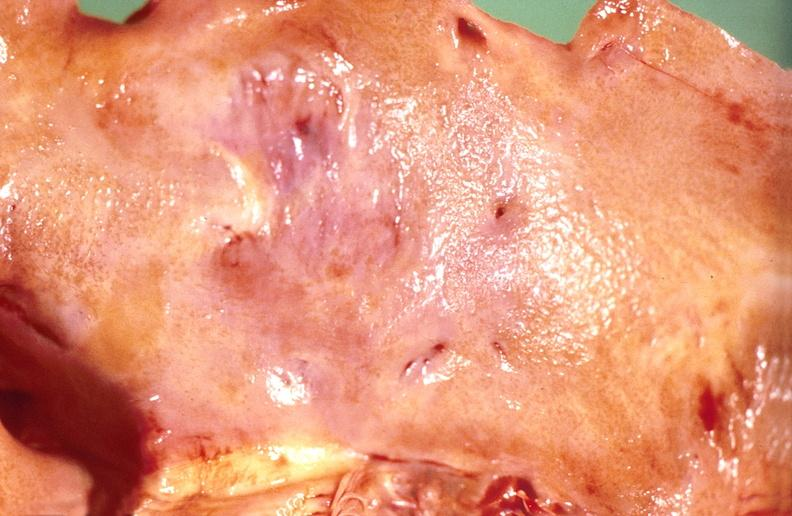s cardiovascular present?
Answer the question using a single word or phrase. Yes 